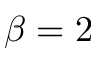Convert formula to latex. <formula><loc_0><loc_0><loc_500><loc_500>\beta = 2</formula> 